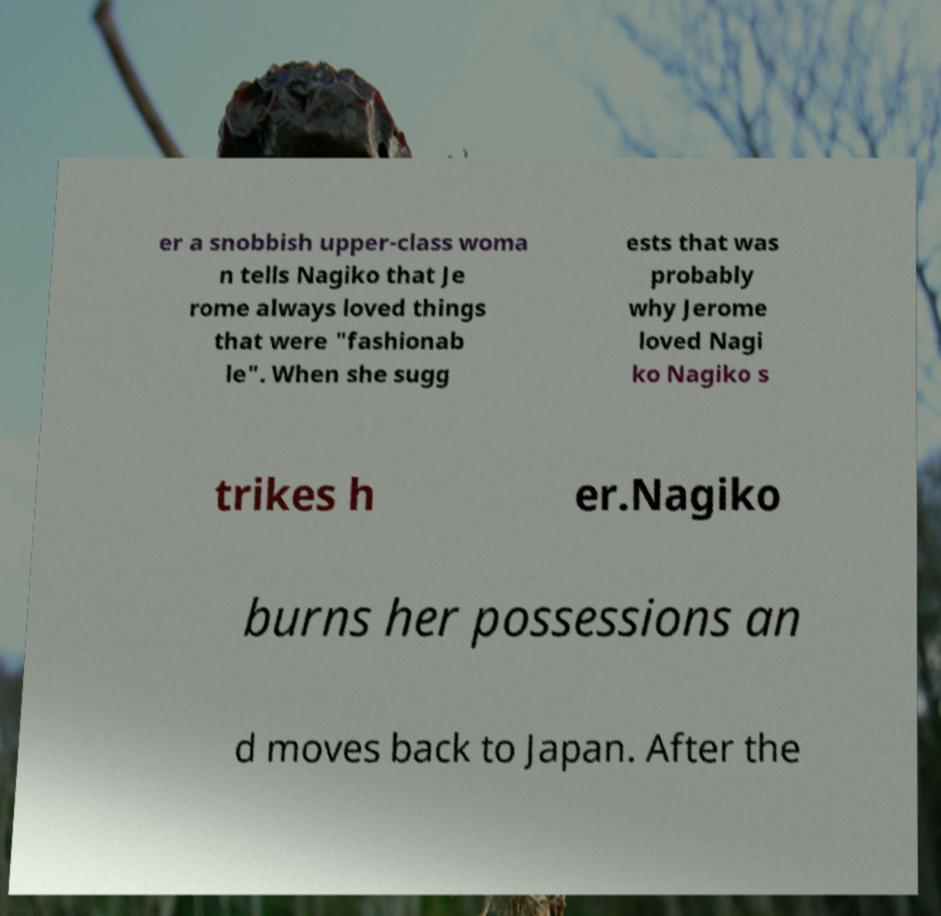Please read and relay the text visible in this image. What does it say? er a snobbish upper-class woma n tells Nagiko that Je rome always loved things that were "fashionab le". When she sugg ests that was probably why Jerome loved Nagi ko Nagiko s trikes h er.Nagiko burns her possessions an d moves back to Japan. After the 